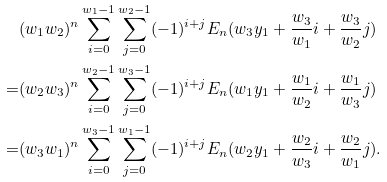Convert formula to latex. <formula><loc_0><loc_0><loc_500><loc_500>& ( w _ { 1 } w _ { 2 } ) ^ { n } \sum _ { i = 0 } ^ { w _ { 1 } - 1 } \sum _ { j = 0 } ^ { w _ { 2 } - 1 } ( - 1 ) ^ { i + j } E _ { n } ( w _ { 3 } y _ { 1 } + \frac { w _ { 3 } } { w _ { 1 } } i + \frac { w _ { 3 } } { w _ { 2 } } j ) \\ = & ( w _ { 2 } w _ { 3 } ) ^ { n } \sum _ { i = 0 } ^ { w _ { 2 } - 1 } \sum _ { j = 0 } ^ { w _ { 3 } - 1 } ( - 1 ) ^ { i + j } E _ { n } ( w _ { 1 } y _ { 1 } + \frac { w _ { 1 } } { w _ { 2 } } i + \frac { w _ { 1 } } { w _ { 3 } } j ) \\ = & ( w _ { 3 } w _ { 1 } ) ^ { n } \sum _ { i = 0 } ^ { w _ { 3 } - 1 } \sum _ { j = 0 } ^ { w _ { 1 } - 1 } ( - 1 ) ^ { i + j } E _ { n } ( w _ { 2 } y _ { 1 } + \frac { w _ { 2 } } { w _ { 3 } } i + \frac { w _ { 2 } } { w _ { 1 } } j ) .</formula> 